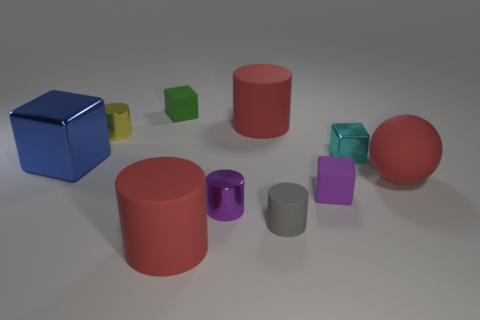Subtract all small gray matte cylinders. How many cylinders are left? 4 Subtract all purple cubes. How many cubes are left? 3 Subtract 1 cubes. How many cubes are left? 3 Subtract all cyan cylinders. Subtract all brown cubes. How many cylinders are left? 5 Subtract 0 blue cylinders. How many objects are left? 10 Subtract all blocks. How many objects are left? 6 Subtract all large brown spheres. Subtract all big red rubber cylinders. How many objects are left? 8 Add 5 tiny green matte cubes. How many tiny green matte cubes are left? 6 Add 5 big red objects. How many big red objects exist? 8 